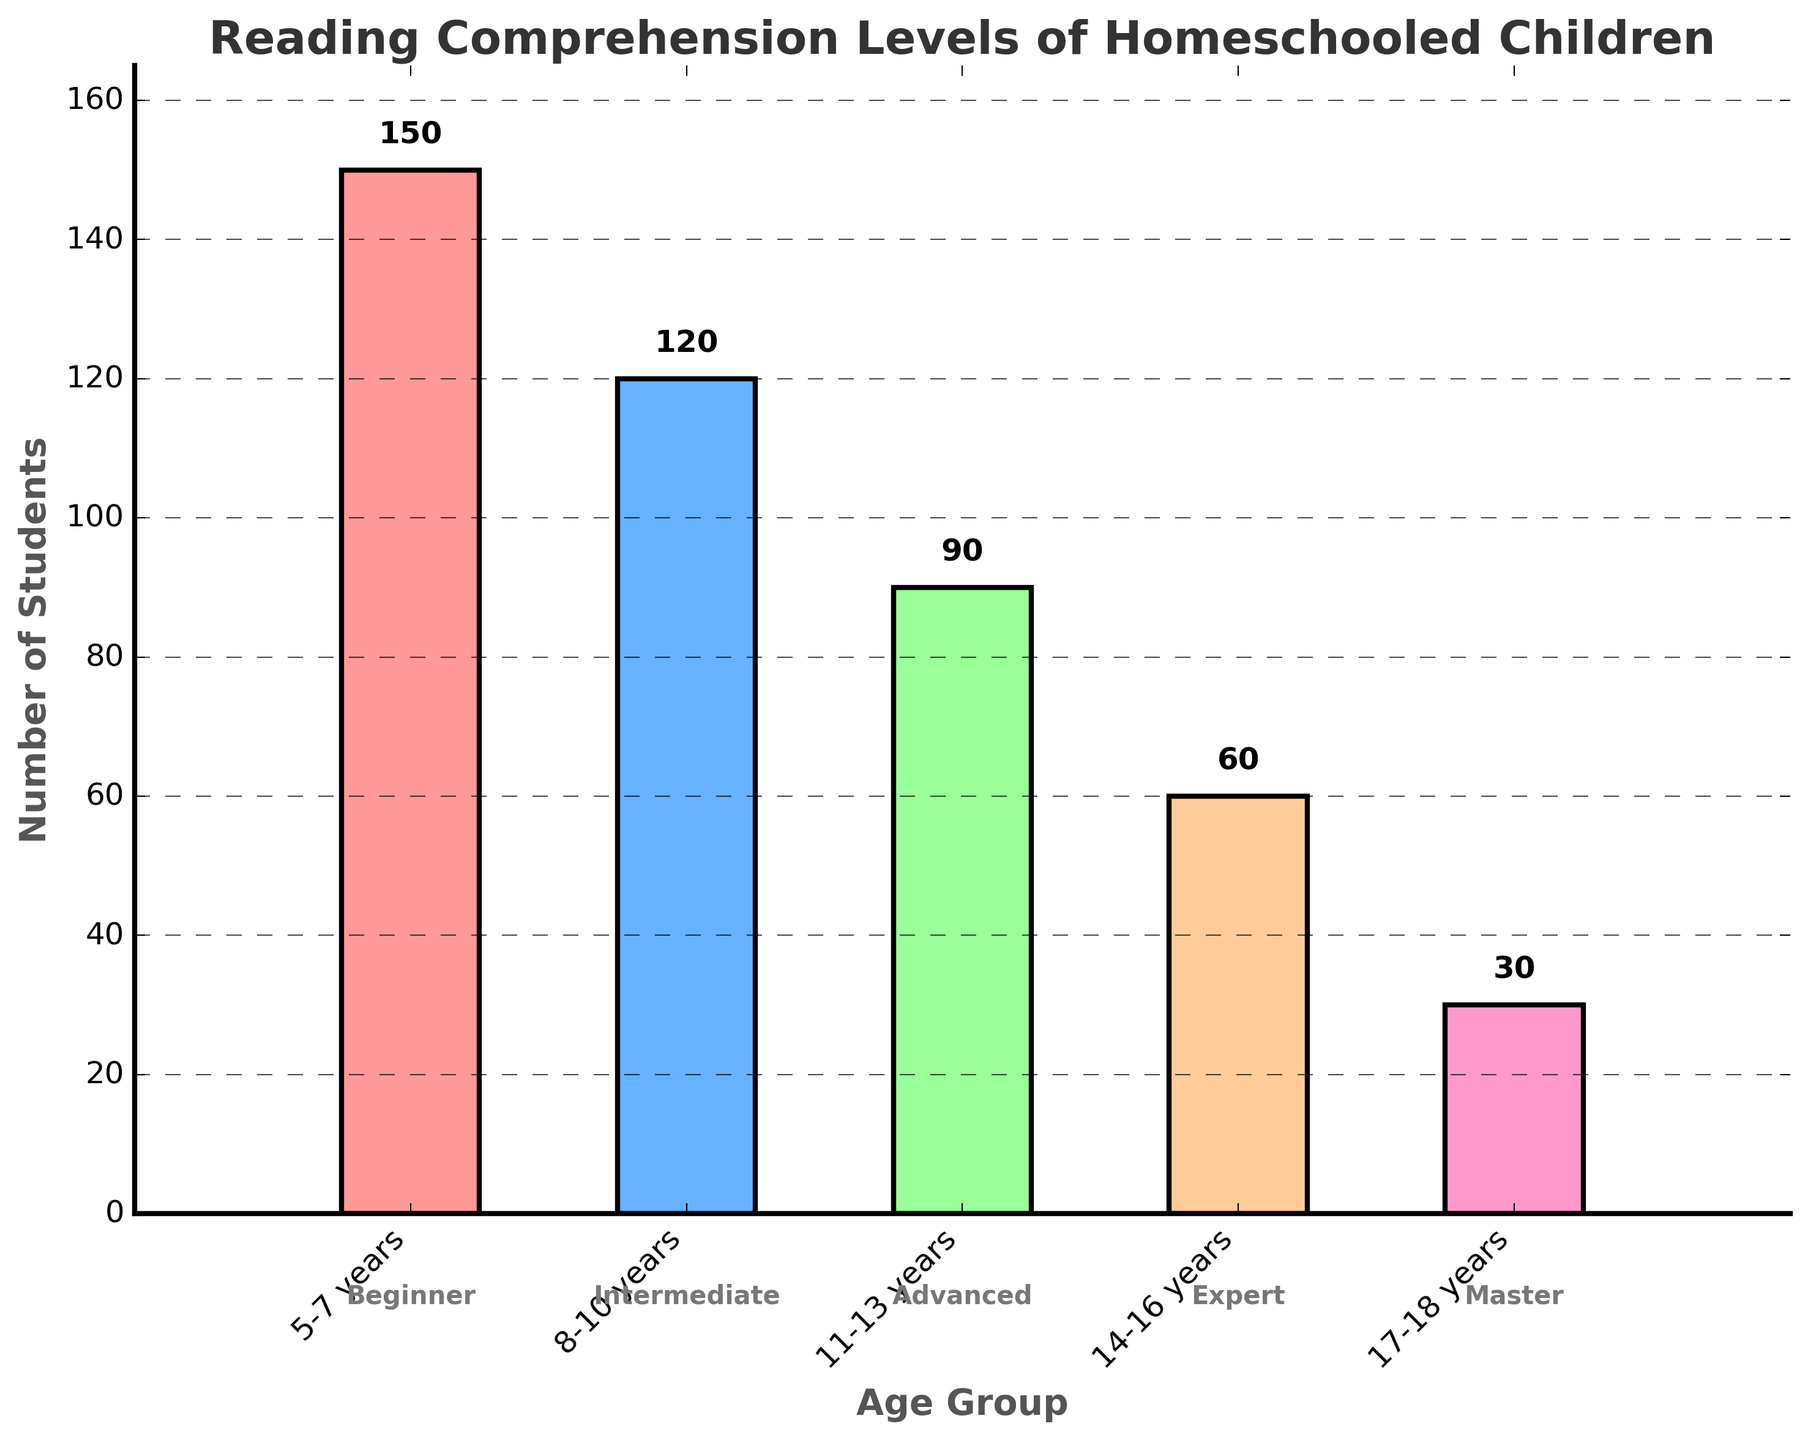What's the title of the chart? The title of the chart is positioned at the top and is typically in a larger font to provide a clear indication of what the chart represents. In this chart, the title reads "Reading Comprehension Levels of Homeschooled Children".
Answer: Reading Comprehension Levels of Homeschooled Children How many age groups are represented in the chart? By examining the x-axis labels and the distinct bars in the bar chart, it is clear that there are five age groups represented.
Answer: Five Which age group has the smallest number of students? The height of the bars represents the number of students in each age group. The bar corresponding to the "17-18 years" age group is the shortest.
Answer: 17-18 years What's the total number of students represented in the chart? To find the total number of students, sum the values of all the bars: 150 + 120 + 90 + 60 + 30. Therefore, the total number of students is 450.
Answer: 450 What is the difference in the number of students between the 5-7 years age group and the 14-16 years age group? The number of students in the 5-7 years age group is 150, and in the 14-16 years age group is 60. The difference is calculated as 150 - 60. So, the difference is 90.
Answer: 90 Which age group has an intermediate reading comprehension level? The levels of the reading comprehension associated with each age group are written below the x-axis labels. The "8-10 years" age group has the label "Intermediate" beneath it.
Answer: 8-10 years Are there more students in the Advanced level or the Expert level? By comparing the heights of the bars for the "11-13 years" (Advanced) and "14-16 years" (Expert) age groups, it is clear that there are more students in the Advanced level (90) than in the Expert level (60).
Answer: Advanced level How many students fall into the Master reading comprehension level? The number of students in the Master level, represented by the "17-18 years" age group, is indicated by the bar height and the numerical label above it, which shows 30 students.
Answer: 30 What's the average number of students across all age groups? To find the average, sum the number of students in all age groups and divide by the number of age groups: (150 + 120 + 90 + 60 + 30) / 5. This results in 450 / 5 = 90.
Answer: 90 